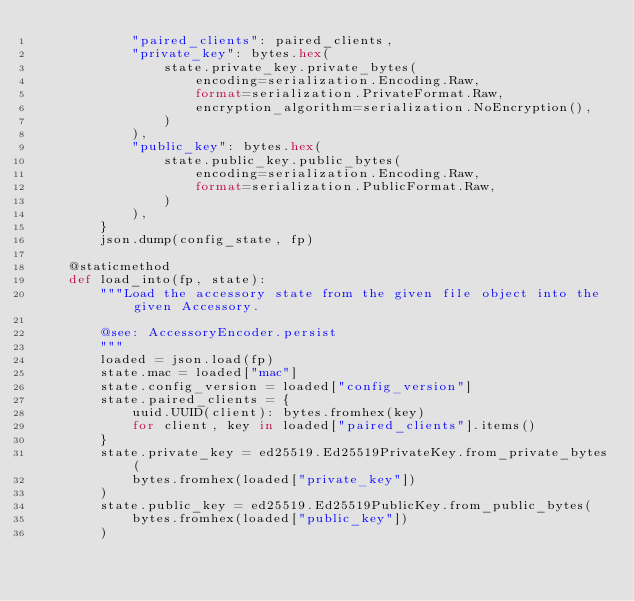Convert code to text. <code><loc_0><loc_0><loc_500><loc_500><_Python_>            "paired_clients": paired_clients,
            "private_key": bytes.hex(
                state.private_key.private_bytes(
                    encoding=serialization.Encoding.Raw,
                    format=serialization.PrivateFormat.Raw,
                    encryption_algorithm=serialization.NoEncryption(),
                )
            ),
            "public_key": bytes.hex(
                state.public_key.public_bytes(
                    encoding=serialization.Encoding.Raw,
                    format=serialization.PublicFormat.Raw,
                )
            ),
        }
        json.dump(config_state, fp)

    @staticmethod
    def load_into(fp, state):
        """Load the accessory state from the given file object into the given Accessory.

        @see: AccessoryEncoder.persist
        """
        loaded = json.load(fp)
        state.mac = loaded["mac"]
        state.config_version = loaded["config_version"]
        state.paired_clients = {
            uuid.UUID(client): bytes.fromhex(key)
            for client, key in loaded["paired_clients"].items()
        }
        state.private_key = ed25519.Ed25519PrivateKey.from_private_bytes(
            bytes.fromhex(loaded["private_key"])
        )
        state.public_key = ed25519.Ed25519PublicKey.from_public_bytes(
            bytes.fromhex(loaded["public_key"])
        )
</code> 